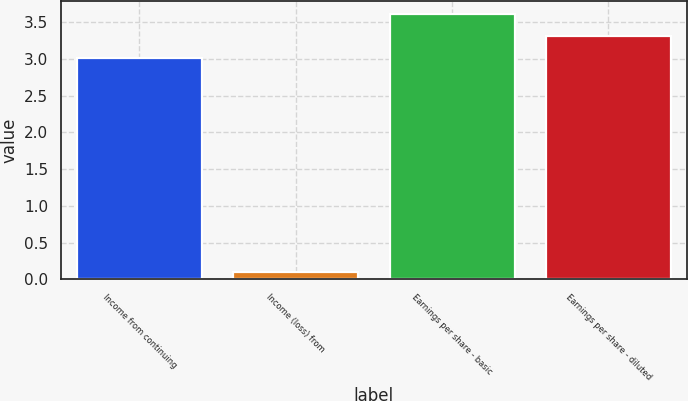Convert chart to OTSL. <chart><loc_0><loc_0><loc_500><loc_500><bar_chart><fcel>Income from continuing<fcel>Income (loss) from<fcel>Earnings per share - basic<fcel>Earnings per share - diluted<nl><fcel>3.01<fcel>0.1<fcel>3.61<fcel>3.31<nl></chart> 